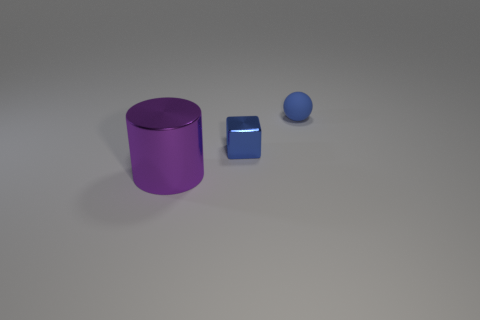There is a metal thing that is on the right side of the large metallic cylinder; does it have the same size as the purple object that is on the left side of the small blue rubber ball?
Offer a very short reply. No. There is a thing that is both in front of the small blue matte ball and on the right side of the purple shiny cylinder; what is its material?
Provide a short and direct response. Metal. Are there fewer matte objects than large green rubber cylinders?
Your answer should be compact. No. What is the size of the metal thing that is on the right side of the object that is on the left side of the block?
Your answer should be compact. Small. There is a thing behind the tiny thing that is to the left of the tiny blue object that is behind the tiny blue cube; what is its shape?
Provide a short and direct response. Sphere. There is a large object that is made of the same material as the blue cube; what is its color?
Your answer should be compact. Purple. What color is the shiny thing that is to the right of the purple metallic thing that is left of the tiny blue thing behind the small block?
Provide a succinct answer. Blue. What number of blocks are tiny things or tiny brown rubber things?
Your answer should be very brief. 1. There is a object that is the same color as the small sphere; what is its material?
Offer a terse response. Metal. Do the cylinder and the thing that is to the right of the tiny blue metal cube have the same color?
Offer a terse response. No. 